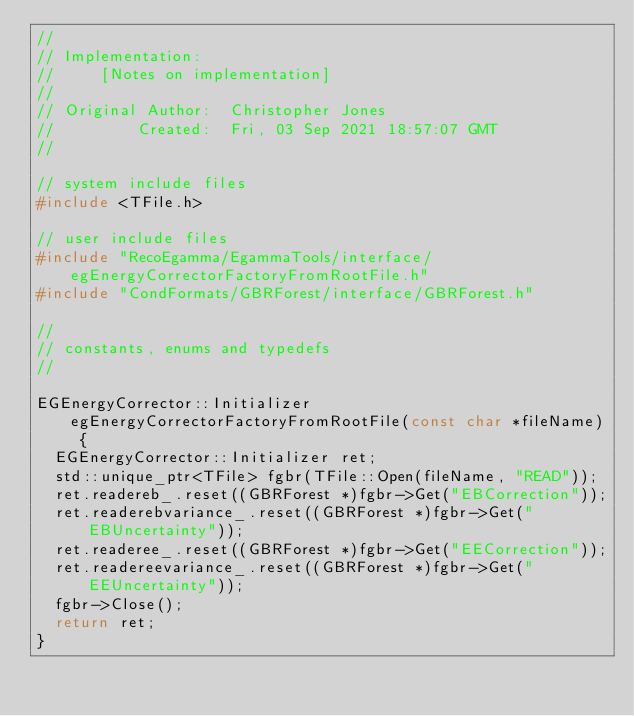Convert code to text. <code><loc_0><loc_0><loc_500><loc_500><_C++_>//
// Implementation:
//     [Notes on implementation]
//
// Original Author:  Christopher Jones
//         Created:  Fri, 03 Sep 2021 18:57:07 GMT
//

// system include files
#include <TFile.h>

// user include files
#include "RecoEgamma/EgammaTools/interface/egEnergyCorrectorFactoryFromRootFile.h"
#include "CondFormats/GBRForest/interface/GBRForest.h"

//
// constants, enums and typedefs
//

EGEnergyCorrector::Initializer egEnergyCorrectorFactoryFromRootFile(const char *fileName) {
  EGEnergyCorrector::Initializer ret;
  std::unique_ptr<TFile> fgbr(TFile::Open(fileName, "READ"));
  ret.readereb_.reset((GBRForest *)fgbr->Get("EBCorrection"));
  ret.readerebvariance_.reset((GBRForest *)fgbr->Get("EBUncertainty"));
  ret.readeree_.reset((GBRForest *)fgbr->Get("EECorrection"));
  ret.readereevariance_.reset((GBRForest *)fgbr->Get("EEUncertainty"));
  fgbr->Close();
  return ret;
}
</code> 